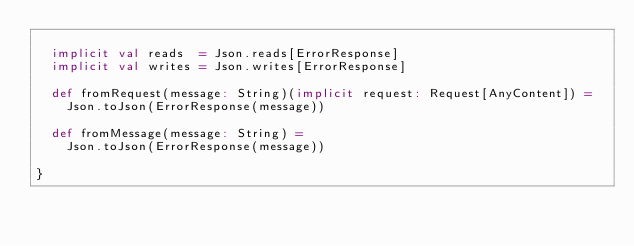<code> <loc_0><loc_0><loc_500><loc_500><_Scala_>
  implicit val reads  = Json.reads[ErrorResponse]
  implicit val writes = Json.writes[ErrorResponse]

  def fromRequest(message: String)(implicit request: Request[AnyContent]) =
    Json.toJson(ErrorResponse(message))

  def fromMessage(message: String) =
    Json.toJson(ErrorResponse(message))

}

</code> 